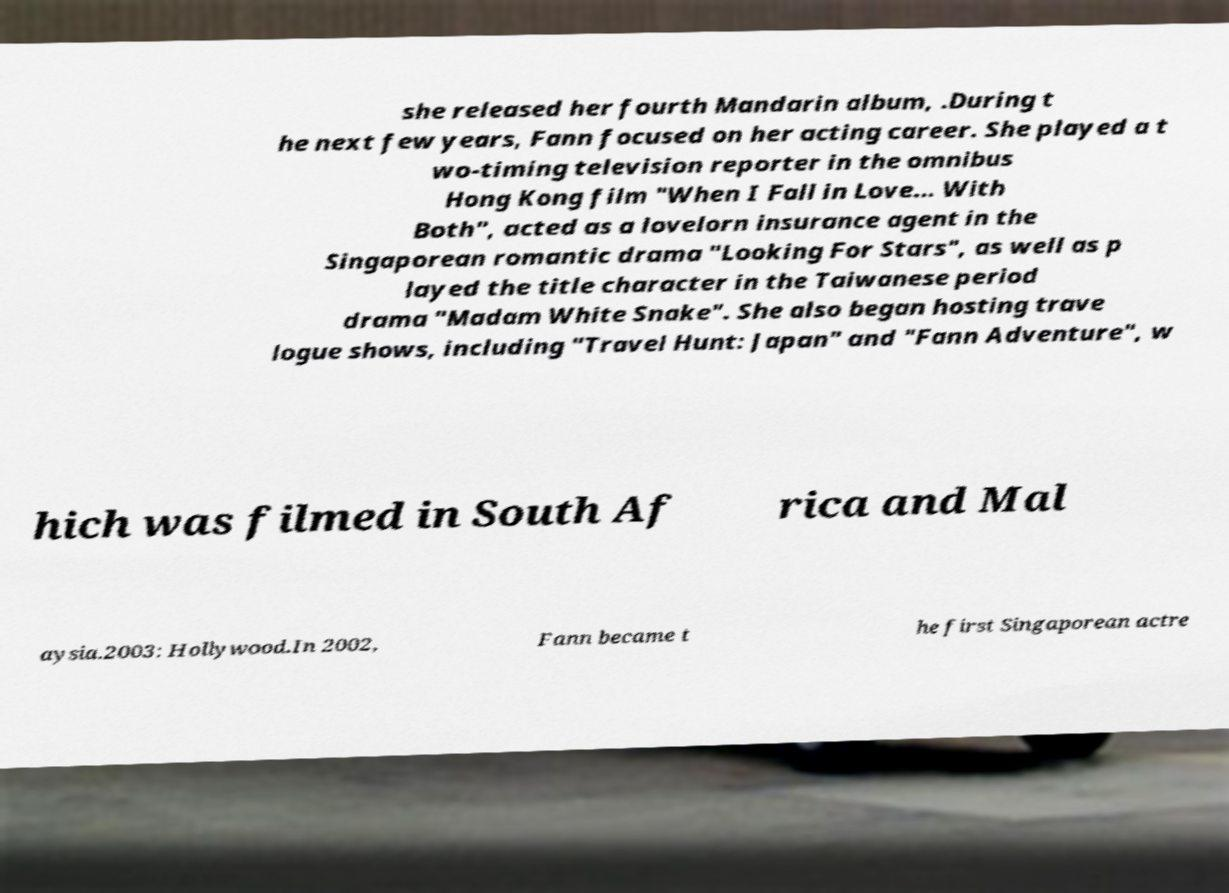Please identify and transcribe the text found in this image. she released her fourth Mandarin album, .During t he next few years, Fann focused on her acting career. She played a t wo-timing television reporter in the omnibus Hong Kong film "When I Fall in Love... With Both", acted as a lovelorn insurance agent in the Singaporean romantic drama "Looking For Stars", as well as p layed the title character in the Taiwanese period drama "Madam White Snake". She also began hosting trave logue shows, including "Travel Hunt: Japan" and "Fann Adventure", w hich was filmed in South Af rica and Mal aysia.2003: Hollywood.In 2002, Fann became t he first Singaporean actre 